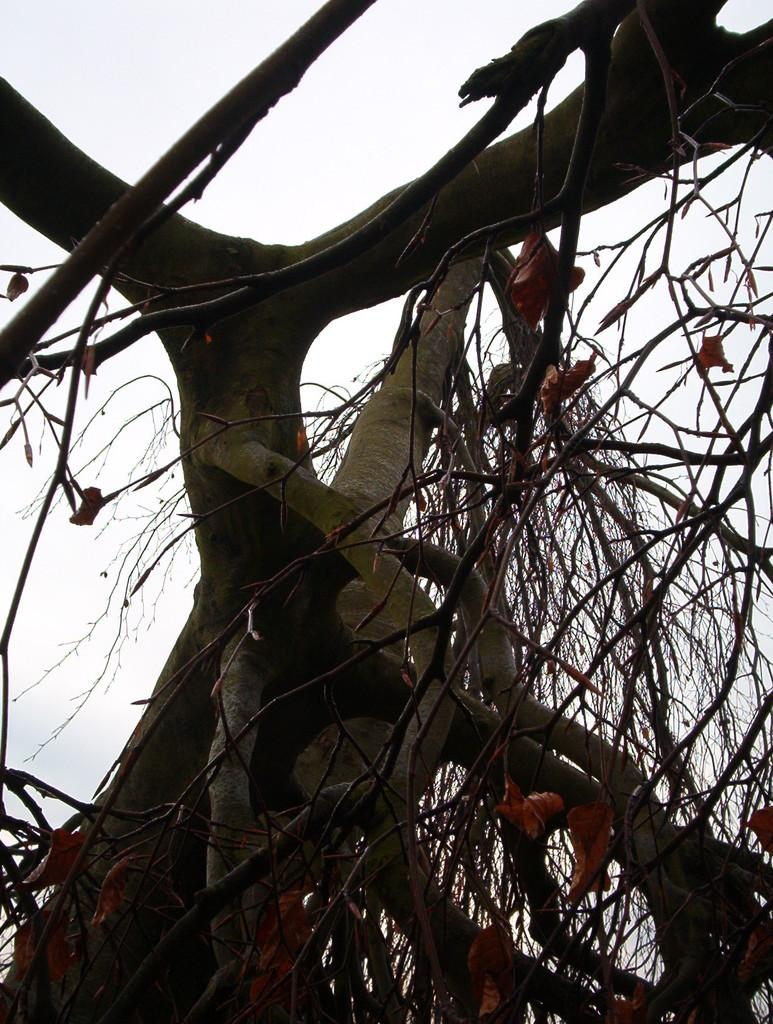What type of vegetation can be seen in the image? There are trees in the image. What else is visible in the image besides the trees? The sky is visible in the image. Can you describe the sky in the image? The sky appears to be cloudy in the image. What type of loaf is being baked in the sky in the image? There is no loaf present in the image, nor is there any indication of baking or any sky-related activity involving a loaf. 